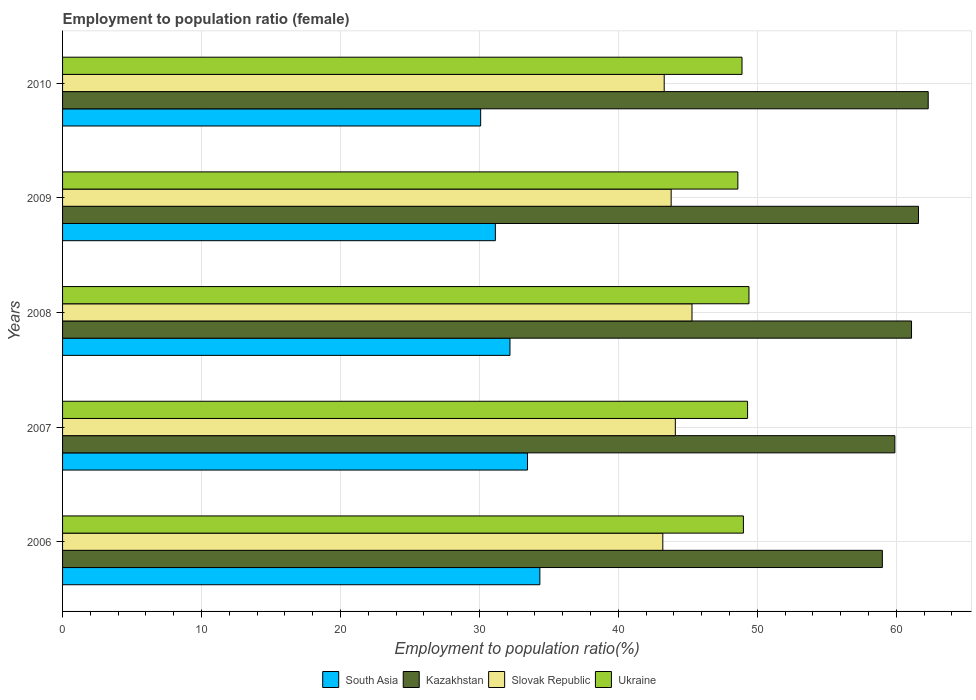How many groups of bars are there?
Your answer should be very brief. 5. Are the number of bars per tick equal to the number of legend labels?
Offer a very short reply. Yes. Are the number of bars on each tick of the Y-axis equal?
Offer a terse response. Yes. What is the label of the 1st group of bars from the top?
Your response must be concise. 2010. What is the employment to population ratio in Slovak Republic in 2007?
Your answer should be very brief. 44.1. Across all years, what is the maximum employment to population ratio in South Asia?
Give a very brief answer. 34.35. Across all years, what is the minimum employment to population ratio in South Asia?
Give a very brief answer. 30.09. In which year was the employment to population ratio in South Asia minimum?
Keep it short and to the point. 2010. What is the total employment to population ratio in Ukraine in the graph?
Provide a short and direct response. 245.2. What is the difference between the employment to population ratio in Slovak Republic in 2006 and that in 2010?
Give a very brief answer. -0.1. What is the difference between the employment to population ratio in Kazakhstan in 2010 and the employment to population ratio in South Asia in 2007?
Offer a very short reply. 28.84. What is the average employment to population ratio in South Asia per year?
Provide a short and direct response. 32.25. In the year 2009, what is the difference between the employment to population ratio in Ukraine and employment to population ratio in Slovak Republic?
Provide a short and direct response. 4.8. In how many years, is the employment to population ratio in South Asia greater than 30 %?
Make the answer very short. 5. What is the ratio of the employment to population ratio in South Asia in 2007 to that in 2010?
Ensure brevity in your answer.  1.11. Is the employment to population ratio in Kazakhstan in 2008 less than that in 2009?
Give a very brief answer. Yes. What is the difference between the highest and the second highest employment to population ratio in Slovak Republic?
Your response must be concise. 1.2. What is the difference between the highest and the lowest employment to population ratio in South Asia?
Offer a very short reply. 4.26. Is the sum of the employment to population ratio in South Asia in 2007 and 2010 greater than the maximum employment to population ratio in Ukraine across all years?
Make the answer very short. Yes. Is it the case that in every year, the sum of the employment to population ratio in Kazakhstan and employment to population ratio in Slovak Republic is greater than the sum of employment to population ratio in Ukraine and employment to population ratio in South Asia?
Make the answer very short. Yes. What does the 3rd bar from the top in 2010 represents?
Your response must be concise. Kazakhstan. What does the 4th bar from the bottom in 2009 represents?
Provide a succinct answer. Ukraine. Are the values on the major ticks of X-axis written in scientific E-notation?
Your response must be concise. No. Where does the legend appear in the graph?
Offer a terse response. Bottom center. How many legend labels are there?
Offer a very short reply. 4. How are the legend labels stacked?
Your response must be concise. Horizontal. What is the title of the graph?
Your answer should be very brief. Employment to population ratio (female). What is the Employment to population ratio(%) in South Asia in 2006?
Ensure brevity in your answer.  34.35. What is the Employment to population ratio(%) of Kazakhstan in 2006?
Provide a succinct answer. 59. What is the Employment to population ratio(%) in Slovak Republic in 2006?
Provide a succinct answer. 43.2. What is the Employment to population ratio(%) of Ukraine in 2006?
Your response must be concise. 49. What is the Employment to population ratio(%) of South Asia in 2007?
Offer a very short reply. 33.46. What is the Employment to population ratio(%) in Kazakhstan in 2007?
Offer a very short reply. 59.9. What is the Employment to population ratio(%) of Slovak Republic in 2007?
Ensure brevity in your answer.  44.1. What is the Employment to population ratio(%) in Ukraine in 2007?
Your response must be concise. 49.3. What is the Employment to population ratio(%) in South Asia in 2008?
Keep it short and to the point. 32.2. What is the Employment to population ratio(%) of Kazakhstan in 2008?
Your response must be concise. 61.1. What is the Employment to population ratio(%) of Slovak Republic in 2008?
Ensure brevity in your answer.  45.3. What is the Employment to population ratio(%) of Ukraine in 2008?
Offer a terse response. 49.4. What is the Employment to population ratio(%) of South Asia in 2009?
Provide a short and direct response. 31.15. What is the Employment to population ratio(%) in Kazakhstan in 2009?
Offer a very short reply. 61.6. What is the Employment to population ratio(%) in Slovak Republic in 2009?
Your response must be concise. 43.8. What is the Employment to population ratio(%) in Ukraine in 2009?
Provide a short and direct response. 48.6. What is the Employment to population ratio(%) of South Asia in 2010?
Provide a short and direct response. 30.09. What is the Employment to population ratio(%) in Kazakhstan in 2010?
Keep it short and to the point. 62.3. What is the Employment to population ratio(%) in Slovak Republic in 2010?
Make the answer very short. 43.3. What is the Employment to population ratio(%) in Ukraine in 2010?
Your response must be concise. 48.9. Across all years, what is the maximum Employment to population ratio(%) in South Asia?
Your response must be concise. 34.35. Across all years, what is the maximum Employment to population ratio(%) of Kazakhstan?
Make the answer very short. 62.3. Across all years, what is the maximum Employment to population ratio(%) of Slovak Republic?
Provide a succinct answer. 45.3. Across all years, what is the maximum Employment to population ratio(%) in Ukraine?
Your answer should be very brief. 49.4. Across all years, what is the minimum Employment to population ratio(%) of South Asia?
Offer a terse response. 30.09. Across all years, what is the minimum Employment to population ratio(%) in Slovak Republic?
Ensure brevity in your answer.  43.2. Across all years, what is the minimum Employment to population ratio(%) of Ukraine?
Offer a very short reply. 48.6. What is the total Employment to population ratio(%) in South Asia in the graph?
Ensure brevity in your answer.  161.25. What is the total Employment to population ratio(%) of Kazakhstan in the graph?
Make the answer very short. 303.9. What is the total Employment to population ratio(%) of Slovak Republic in the graph?
Make the answer very short. 219.7. What is the total Employment to population ratio(%) in Ukraine in the graph?
Offer a terse response. 245.2. What is the difference between the Employment to population ratio(%) in South Asia in 2006 and that in 2007?
Your answer should be very brief. 0.89. What is the difference between the Employment to population ratio(%) in Slovak Republic in 2006 and that in 2007?
Give a very brief answer. -0.9. What is the difference between the Employment to population ratio(%) in Ukraine in 2006 and that in 2007?
Your answer should be very brief. -0.3. What is the difference between the Employment to population ratio(%) of South Asia in 2006 and that in 2008?
Provide a short and direct response. 2.15. What is the difference between the Employment to population ratio(%) of Slovak Republic in 2006 and that in 2008?
Provide a succinct answer. -2.1. What is the difference between the Employment to population ratio(%) in South Asia in 2006 and that in 2009?
Keep it short and to the point. 3.2. What is the difference between the Employment to population ratio(%) of Slovak Republic in 2006 and that in 2009?
Your answer should be very brief. -0.6. What is the difference between the Employment to population ratio(%) in Ukraine in 2006 and that in 2009?
Provide a short and direct response. 0.4. What is the difference between the Employment to population ratio(%) of South Asia in 2006 and that in 2010?
Provide a succinct answer. 4.26. What is the difference between the Employment to population ratio(%) in Kazakhstan in 2006 and that in 2010?
Make the answer very short. -3.3. What is the difference between the Employment to population ratio(%) in Ukraine in 2006 and that in 2010?
Give a very brief answer. 0.1. What is the difference between the Employment to population ratio(%) in South Asia in 2007 and that in 2008?
Your answer should be compact. 1.26. What is the difference between the Employment to population ratio(%) in South Asia in 2007 and that in 2009?
Keep it short and to the point. 2.31. What is the difference between the Employment to population ratio(%) of Kazakhstan in 2007 and that in 2009?
Your response must be concise. -1.7. What is the difference between the Employment to population ratio(%) in Slovak Republic in 2007 and that in 2009?
Make the answer very short. 0.3. What is the difference between the Employment to population ratio(%) of South Asia in 2007 and that in 2010?
Offer a terse response. 3.37. What is the difference between the Employment to population ratio(%) in Kazakhstan in 2007 and that in 2010?
Offer a terse response. -2.4. What is the difference between the Employment to population ratio(%) in South Asia in 2008 and that in 2009?
Give a very brief answer. 1.05. What is the difference between the Employment to population ratio(%) in Ukraine in 2008 and that in 2009?
Ensure brevity in your answer.  0.8. What is the difference between the Employment to population ratio(%) in South Asia in 2008 and that in 2010?
Make the answer very short. 2.11. What is the difference between the Employment to population ratio(%) in South Asia in 2009 and that in 2010?
Ensure brevity in your answer.  1.06. What is the difference between the Employment to population ratio(%) in Ukraine in 2009 and that in 2010?
Give a very brief answer. -0.3. What is the difference between the Employment to population ratio(%) of South Asia in 2006 and the Employment to population ratio(%) of Kazakhstan in 2007?
Ensure brevity in your answer.  -25.55. What is the difference between the Employment to population ratio(%) in South Asia in 2006 and the Employment to population ratio(%) in Slovak Republic in 2007?
Ensure brevity in your answer.  -9.75. What is the difference between the Employment to population ratio(%) of South Asia in 2006 and the Employment to population ratio(%) of Ukraine in 2007?
Your answer should be very brief. -14.95. What is the difference between the Employment to population ratio(%) of Slovak Republic in 2006 and the Employment to population ratio(%) of Ukraine in 2007?
Keep it short and to the point. -6.1. What is the difference between the Employment to population ratio(%) in South Asia in 2006 and the Employment to population ratio(%) in Kazakhstan in 2008?
Provide a short and direct response. -26.75. What is the difference between the Employment to population ratio(%) in South Asia in 2006 and the Employment to population ratio(%) in Slovak Republic in 2008?
Offer a very short reply. -10.95. What is the difference between the Employment to population ratio(%) in South Asia in 2006 and the Employment to population ratio(%) in Ukraine in 2008?
Make the answer very short. -15.05. What is the difference between the Employment to population ratio(%) in Kazakhstan in 2006 and the Employment to population ratio(%) in Slovak Republic in 2008?
Ensure brevity in your answer.  13.7. What is the difference between the Employment to population ratio(%) in South Asia in 2006 and the Employment to population ratio(%) in Kazakhstan in 2009?
Keep it short and to the point. -27.25. What is the difference between the Employment to population ratio(%) in South Asia in 2006 and the Employment to population ratio(%) in Slovak Republic in 2009?
Your response must be concise. -9.45. What is the difference between the Employment to population ratio(%) in South Asia in 2006 and the Employment to population ratio(%) in Ukraine in 2009?
Your response must be concise. -14.25. What is the difference between the Employment to population ratio(%) in Kazakhstan in 2006 and the Employment to population ratio(%) in Ukraine in 2009?
Your answer should be very brief. 10.4. What is the difference between the Employment to population ratio(%) in Slovak Republic in 2006 and the Employment to population ratio(%) in Ukraine in 2009?
Your answer should be very brief. -5.4. What is the difference between the Employment to population ratio(%) of South Asia in 2006 and the Employment to population ratio(%) of Kazakhstan in 2010?
Your answer should be compact. -27.95. What is the difference between the Employment to population ratio(%) of South Asia in 2006 and the Employment to population ratio(%) of Slovak Republic in 2010?
Your answer should be compact. -8.95. What is the difference between the Employment to population ratio(%) in South Asia in 2006 and the Employment to population ratio(%) in Ukraine in 2010?
Ensure brevity in your answer.  -14.55. What is the difference between the Employment to population ratio(%) in Kazakhstan in 2006 and the Employment to population ratio(%) in Ukraine in 2010?
Ensure brevity in your answer.  10.1. What is the difference between the Employment to population ratio(%) in South Asia in 2007 and the Employment to population ratio(%) in Kazakhstan in 2008?
Your response must be concise. -27.64. What is the difference between the Employment to population ratio(%) in South Asia in 2007 and the Employment to population ratio(%) in Slovak Republic in 2008?
Provide a succinct answer. -11.84. What is the difference between the Employment to population ratio(%) in South Asia in 2007 and the Employment to population ratio(%) in Ukraine in 2008?
Ensure brevity in your answer.  -15.94. What is the difference between the Employment to population ratio(%) of Kazakhstan in 2007 and the Employment to population ratio(%) of Slovak Republic in 2008?
Ensure brevity in your answer.  14.6. What is the difference between the Employment to population ratio(%) in Kazakhstan in 2007 and the Employment to population ratio(%) in Ukraine in 2008?
Give a very brief answer. 10.5. What is the difference between the Employment to population ratio(%) in Slovak Republic in 2007 and the Employment to population ratio(%) in Ukraine in 2008?
Your answer should be very brief. -5.3. What is the difference between the Employment to population ratio(%) in South Asia in 2007 and the Employment to population ratio(%) in Kazakhstan in 2009?
Ensure brevity in your answer.  -28.14. What is the difference between the Employment to population ratio(%) in South Asia in 2007 and the Employment to population ratio(%) in Slovak Republic in 2009?
Give a very brief answer. -10.34. What is the difference between the Employment to population ratio(%) of South Asia in 2007 and the Employment to population ratio(%) of Ukraine in 2009?
Offer a very short reply. -15.14. What is the difference between the Employment to population ratio(%) in Slovak Republic in 2007 and the Employment to population ratio(%) in Ukraine in 2009?
Provide a succinct answer. -4.5. What is the difference between the Employment to population ratio(%) in South Asia in 2007 and the Employment to population ratio(%) in Kazakhstan in 2010?
Ensure brevity in your answer.  -28.84. What is the difference between the Employment to population ratio(%) of South Asia in 2007 and the Employment to population ratio(%) of Slovak Republic in 2010?
Provide a short and direct response. -9.84. What is the difference between the Employment to population ratio(%) of South Asia in 2007 and the Employment to population ratio(%) of Ukraine in 2010?
Provide a short and direct response. -15.44. What is the difference between the Employment to population ratio(%) in Slovak Republic in 2007 and the Employment to population ratio(%) in Ukraine in 2010?
Your answer should be compact. -4.8. What is the difference between the Employment to population ratio(%) in South Asia in 2008 and the Employment to population ratio(%) in Kazakhstan in 2009?
Keep it short and to the point. -29.4. What is the difference between the Employment to population ratio(%) in South Asia in 2008 and the Employment to population ratio(%) in Slovak Republic in 2009?
Give a very brief answer. -11.6. What is the difference between the Employment to population ratio(%) in South Asia in 2008 and the Employment to population ratio(%) in Ukraine in 2009?
Your response must be concise. -16.4. What is the difference between the Employment to population ratio(%) of Kazakhstan in 2008 and the Employment to population ratio(%) of Slovak Republic in 2009?
Provide a short and direct response. 17.3. What is the difference between the Employment to population ratio(%) in South Asia in 2008 and the Employment to population ratio(%) in Kazakhstan in 2010?
Your answer should be very brief. -30.1. What is the difference between the Employment to population ratio(%) of South Asia in 2008 and the Employment to population ratio(%) of Slovak Republic in 2010?
Your answer should be very brief. -11.1. What is the difference between the Employment to population ratio(%) of South Asia in 2008 and the Employment to population ratio(%) of Ukraine in 2010?
Your response must be concise. -16.7. What is the difference between the Employment to population ratio(%) of Kazakhstan in 2008 and the Employment to population ratio(%) of Slovak Republic in 2010?
Your response must be concise. 17.8. What is the difference between the Employment to population ratio(%) in Kazakhstan in 2008 and the Employment to population ratio(%) in Ukraine in 2010?
Offer a very short reply. 12.2. What is the difference between the Employment to population ratio(%) in Slovak Republic in 2008 and the Employment to population ratio(%) in Ukraine in 2010?
Your response must be concise. -3.6. What is the difference between the Employment to population ratio(%) of South Asia in 2009 and the Employment to population ratio(%) of Kazakhstan in 2010?
Make the answer very short. -31.15. What is the difference between the Employment to population ratio(%) in South Asia in 2009 and the Employment to population ratio(%) in Slovak Republic in 2010?
Your answer should be compact. -12.15. What is the difference between the Employment to population ratio(%) in South Asia in 2009 and the Employment to population ratio(%) in Ukraine in 2010?
Keep it short and to the point. -17.75. What is the difference between the Employment to population ratio(%) in Kazakhstan in 2009 and the Employment to population ratio(%) in Slovak Republic in 2010?
Your answer should be compact. 18.3. What is the average Employment to population ratio(%) in South Asia per year?
Your answer should be very brief. 32.25. What is the average Employment to population ratio(%) in Kazakhstan per year?
Offer a terse response. 60.78. What is the average Employment to population ratio(%) in Slovak Republic per year?
Offer a terse response. 43.94. What is the average Employment to population ratio(%) of Ukraine per year?
Your answer should be very brief. 49.04. In the year 2006, what is the difference between the Employment to population ratio(%) in South Asia and Employment to population ratio(%) in Kazakhstan?
Offer a very short reply. -24.65. In the year 2006, what is the difference between the Employment to population ratio(%) in South Asia and Employment to population ratio(%) in Slovak Republic?
Offer a very short reply. -8.85. In the year 2006, what is the difference between the Employment to population ratio(%) of South Asia and Employment to population ratio(%) of Ukraine?
Your response must be concise. -14.65. In the year 2006, what is the difference between the Employment to population ratio(%) in Slovak Republic and Employment to population ratio(%) in Ukraine?
Give a very brief answer. -5.8. In the year 2007, what is the difference between the Employment to population ratio(%) in South Asia and Employment to population ratio(%) in Kazakhstan?
Keep it short and to the point. -26.44. In the year 2007, what is the difference between the Employment to population ratio(%) in South Asia and Employment to population ratio(%) in Slovak Republic?
Give a very brief answer. -10.64. In the year 2007, what is the difference between the Employment to population ratio(%) of South Asia and Employment to population ratio(%) of Ukraine?
Provide a short and direct response. -15.84. In the year 2007, what is the difference between the Employment to population ratio(%) in Kazakhstan and Employment to population ratio(%) in Ukraine?
Offer a very short reply. 10.6. In the year 2007, what is the difference between the Employment to population ratio(%) of Slovak Republic and Employment to population ratio(%) of Ukraine?
Make the answer very short. -5.2. In the year 2008, what is the difference between the Employment to population ratio(%) of South Asia and Employment to population ratio(%) of Kazakhstan?
Your response must be concise. -28.9. In the year 2008, what is the difference between the Employment to population ratio(%) in South Asia and Employment to population ratio(%) in Slovak Republic?
Ensure brevity in your answer.  -13.1. In the year 2008, what is the difference between the Employment to population ratio(%) of South Asia and Employment to population ratio(%) of Ukraine?
Offer a very short reply. -17.2. In the year 2008, what is the difference between the Employment to population ratio(%) in Slovak Republic and Employment to population ratio(%) in Ukraine?
Your answer should be compact. -4.1. In the year 2009, what is the difference between the Employment to population ratio(%) of South Asia and Employment to population ratio(%) of Kazakhstan?
Your answer should be very brief. -30.45. In the year 2009, what is the difference between the Employment to population ratio(%) in South Asia and Employment to population ratio(%) in Slovak Republic?
Provide a short and direct response. -12.65. In the year 2009, what is the difference between the Employment to population ratio(%) of South Asia and Employment to population ratio(%) of Ukraine?
Keep it short and to the point. -17.45. In the year 2009, what is the difference between the Employment to population ratio(%) of Kazakhstan and Employment to population ratio(%) of Slovak Republic?
Provide a short and direct response. 17.8. In the year 2010, what is the difference between the Employment to population ratio(%) in South Asia and Employment to population ratio(%) in Kazakhstan?
Ensure brevity in your answer.  -32.21. In the year 2010, what is the difference between the Employment to population ratio(%) in South Asia and Employment to population ratio(%) in Slovak Republic?
Provide a short and direct response. -13.21. In the year 2010, what is the difference between the Employment to population ratio(%) in South Asia and Employment to population ratio(%) in Ukraine?
Your response must be concise. -18.81. What is the ratio of the Employment to population ratio(%) of South Asia in 2006 to that in 2007?
Provide a succinct answer. 1.03. What is the ratio of the Employment to population ratio(%) of Slovak Republic in 2006 to that in 2007?
Provide a succinct answer. 0.98. What is the ratio of the Employment to population ratio(%) of Ukraine in 2006 to that in 2007?
Ensure brevity in your answer.  0.99. What is the ratio of the Employment to population ratio(%) of South Asia in 2006 to that in 2008?
Provide a short and direct response. 1.07. What is the ratio of the Employment to population ratio(%) of Kazakhstan in 2006 to that in 2008?
Make the answer very short. 0.97. What is the ratio of the Employment to population ratio(%) of Slovak Republic in 2006 to that in 2008?
Make the answer very short. 0.95. What is the ratio of the Employment to population ratio(%) of South Asia in 2006 to that in 2009?
Ensure brevity in your answer.  1.1. What is the ratio of the Employment to population ratio(%) in Kazakhstan in 2006 to that in 2009?
Your answer should be very brief. 0.96. What is the ratio of the Employment to population ratio(%) of Slovak Republic in 2006 to that in 2009?
Give a very brief answer. 0.99. What is the ratio of the Employment to population ratio(%) of Ukraine in 2006 to that in 2009?
Give a very brief answer. 1.01. What is the ratio of the Employment to population ratio(%) in South Asia in 2006 to that in 2010?
Offer a terse response. 1.14. What is the ratio of the Employment to population ratio(%) in Kazakhstan in 2006 to that in 2010?
Your response must be concise. 0.95. What is the ratio of the Employment to population ratio(%) in South Asia in 2007 to that in 2008?
Ensure brevity in your answer.  1.04. What is the ratio of the Employment to population ratio(%) of Kazakhstan in 2007 to that in 2008?
Provide a short and direct response. 0.98. What is the ratio of the Employment to population ratio(%) of Slovak Republic in 2007 to that in 2008?
Offer a terse response. 0.97. What is the ratio of the Employment to population ratio(%) in South Asia in 2007 to that in 2009?
Offer a terse response. 1.07. What is the ratio of the Employment to population ratio(%) in Kazakhstan in 2007 to that in 2009?
Make the answer very short. 0.97. What is the ratio of the Employment to population ratio(%) of Slovak Republic in 2007 to that in 2009?
Your answer should be very brief. 1.01. What is the ratio of the Employment to population ratio(%) of Ukraine in 2007 to that in 2009?
Provide a succinct answer. 1.01. What is the ratio of the Employment to population ratio(%) in South Asia in 2007 to that in 2010?
Provide a short and direct response. 1.11. What is the ratio of the Employment to population ratio(%) of Kazakhstan in 2007 to that in 2010?
Offer a terse response. 0.96. What is the ratio of the Employment to population ratio(%) of Slovak Republic in 2007 to that in 2010?
Make the answer very short. 1.02. What is the ratio of the Employment to population ratio(%) of Ukraine in 2007 to that in 2010?
Offer a terse response. 1.01. What is the ratio of the Employment to population ratio(%) of South Asia in 2008 to that in 2009?
Provide a short and direct response. 1.03. What is the ratio of the Employment to population ratio(%) in Kazakhstan in 2008 to that in 2009?
Offer a terse response. 0.99. What is the ratio of the Employment to population ratio(%) of Slovak Republic in 2008 to that in 2009?
Offer a terse response. 1.03. What is the ratio of the Employment to population ratio(%) of Ukraine in 2008 to that in 2009?
Your answer should be compact. 1.02. What is the ratio of the Employment to population ratio(%) of South Asia in 2008 to that in 2010?
Ensure brevity in your answer.  1.07. What is the ratio of the Employment to population ratio(%) in Kazakhstan in 2008 to that in 2010?
Keep it short and to the point. 0.98. What is the ratio of the Employment to population ratio(%) in Slovak Republic in 2008 to that in 2010?
Your answer should be very brief. 1.05. What is the ratio of the Employment to population ratio(%) of Ukraine in 2008 to that in 2010?
Make the answer very short. 1.01. What is the ratio of the Employment to population ratio(%) of South Asia in 2009 to that in 2010?
Offer a terse response. 1.04. What is the ratio of the Employment to population ratio(%) of Kazakhstan in 2009 to that in 2010?
Provide a succinct answer. 0.99. What is the ratio of the Employment to population ratio(%) of Slovak Republic in 2009 to that in 2010?
Provide a short and direct response. 1.01. What is the ratio of the Employment to population ratio(%) in Ukraine in 2009 to that in 2010?
Keep it short and to the point. 0.99. What is the difference between the highest and the second highest Employment to population ratio(%) in South Asia?
Ensure brevity in your answer.  0.89. What is the difference between the highest and the second highest Employment to population ratio(%) in Slovak Republic?
Give a very brief answer. 1.2. What is the difference between the highest and the lowest Employment to population ratio(%) in South Asia?
Ensure brevity in your answer.  4.26. What is the difference between the highest and the lowest Employment to population ratio(%) in Kazakhstan?
Keep it short and to the point. 3.3. What is the difference between the highest and the lowest Employment to population ratio(%) in Slovak Republic?
Provide a short and direct response. 2.1. 